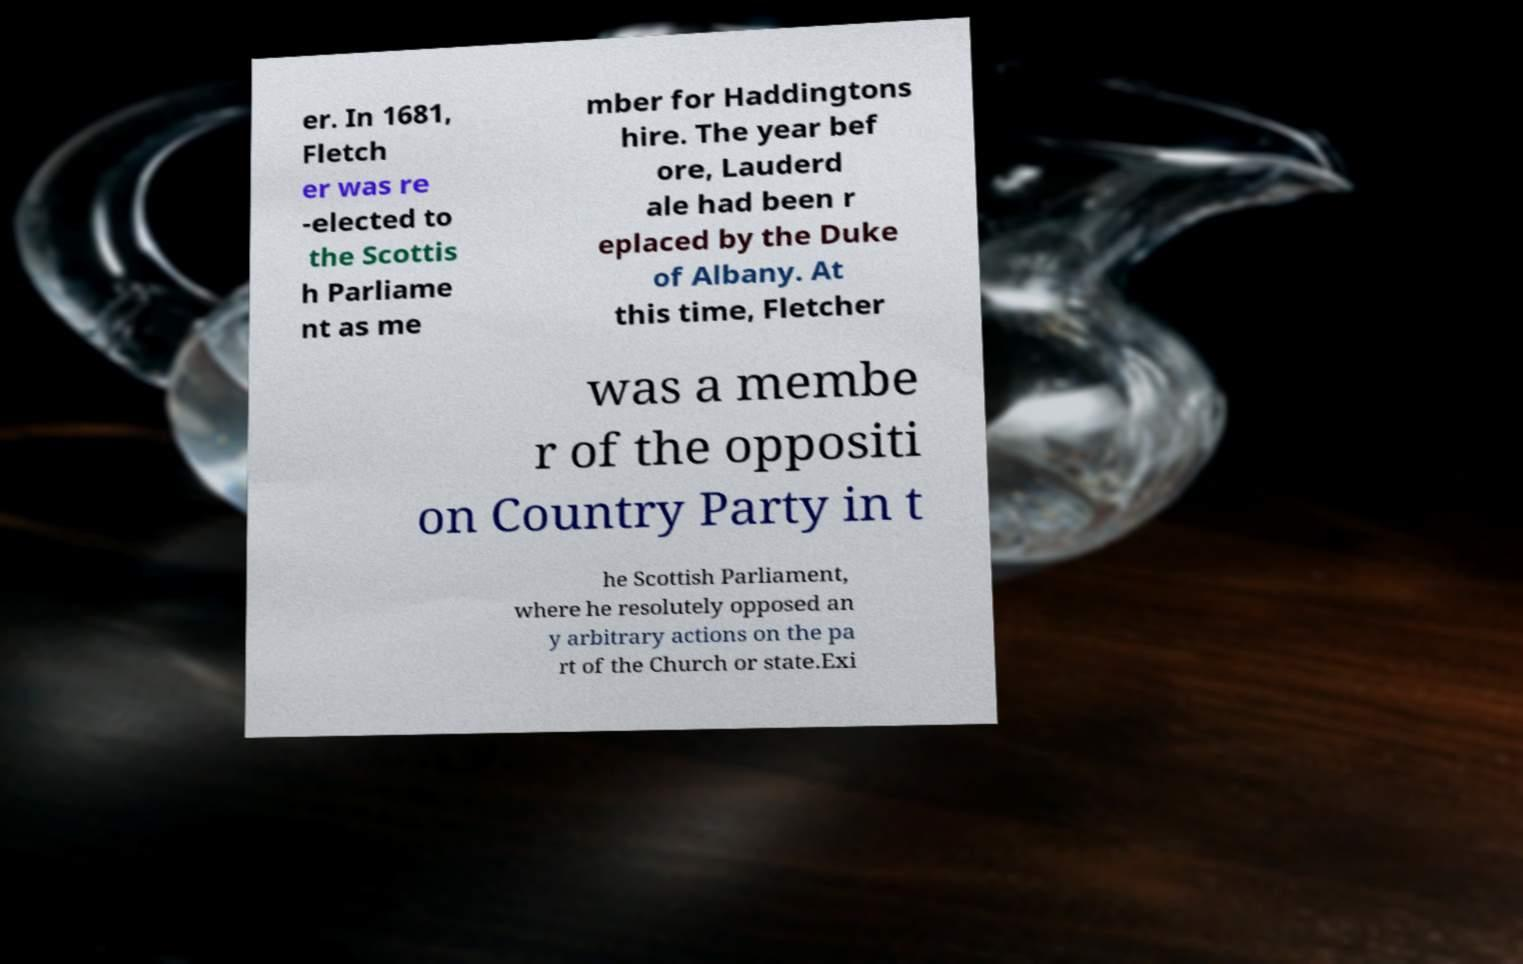Can you accurately transcribe the text from the provided image for me? er. In 1681, Fletch er was re -elected to the Scottis h Parliame nt as me mber for Haddingtons hire. The year bef ore, Lauderd ale had been r eplaced by the Duke of Albany. At this time, Fletcher was a membe r of the oppositi on Country Party in t he Scottish Parliament, where he resolutely opposed an y arbitrary actions on the pa rt of the Church or state.Exi 